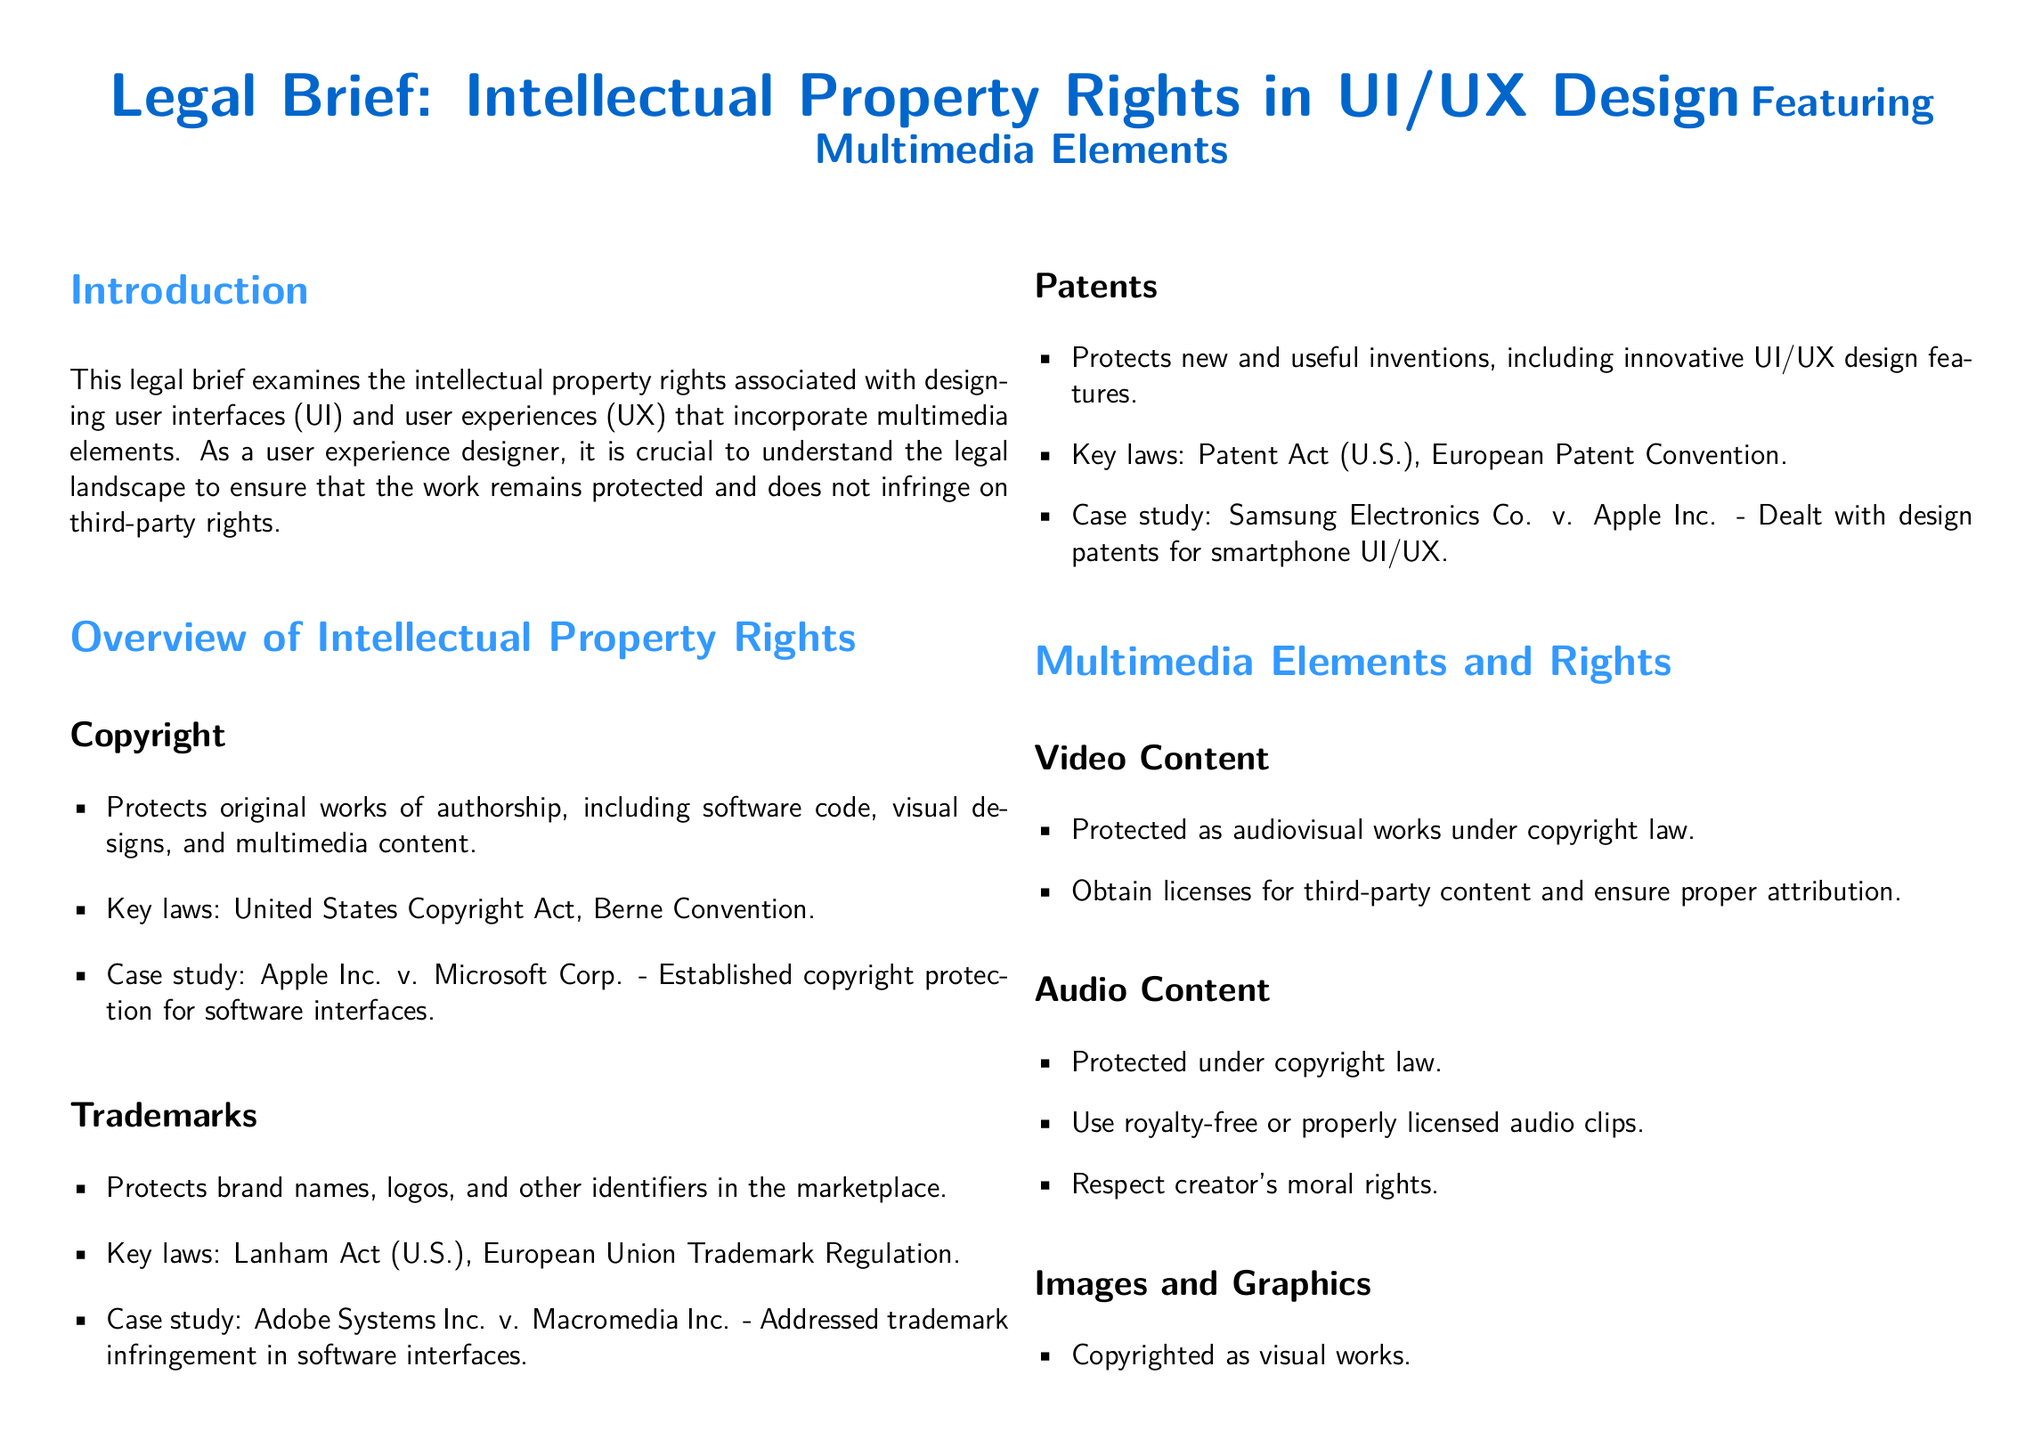What is the main focus of the legal brief? The main focus of the legal brief is to examine the intellectual property rights associated with UI/UX design that incorporates multimedia elements.
Answer: Intellectual property rights in UI/UX design Which Act is related to copyright protection? The document references the United States Copyright Act as the key law for copyright protection.
Answer: United States Copyright Act What multimedia element is specifically mentioned as being protected under copyright law? The document states that video content is protected as audiovisual works under copyright law.
Answer: Video content Which case established copyright protection for software interfaces? The case study mentioned in the document that established this protection is Apple Inc. v. Microsoft Corp.
Answer: Apple Inc. v. Microsoft Corp What should UI/UX designers maintain to ensure compliance? The best practice mentioned in the document includes maintaining thorough documentation of the design process and sources.
Answer: Documentation What type of rights should be respected when using audio content? The document mentions that moral rights of the creator should be respected when using audio content.
Answer: Creator's moral rights What is the legal consultation advice given to UI/UX designers? The brief advises seeking legal consultation to stay updated on relevant laws.
Answer: Seek advice to stay updated In what year was the European Union Trademark Regulation established? The brief does not specify a year for the European Union Trademark Regulation.
Answer: Not specified Which multimedia element is suggested to be sourced from licensed collections? The document suggests that images and graphics should be sourced from licensed collections or created original graphics.
Answer: Images and graphics 